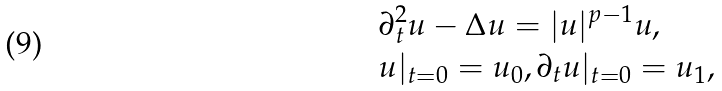<formula> <loc_0><loc_0><loc_500><loc_500>& \partial ^ { 2 } _ { t } u - \Delta u = | u | ^ { p - 1 } u , \\ & u | _ { t = 0 } = u _ { 0 } , \partial _ { t } u | _ { t = 0 } = u _ { 1 } ,</formula> 